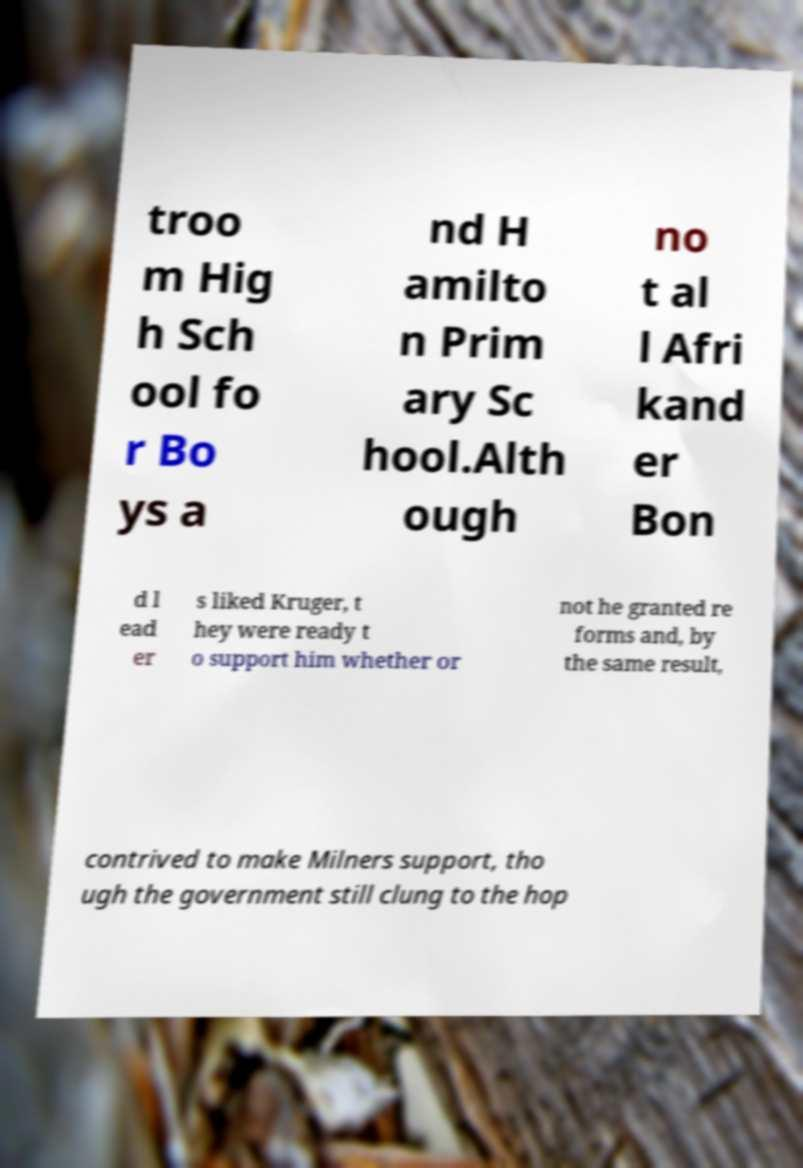Please read and relay the text visible in this image. What does it say? troo m Hig h Sch ool fo r Bo ys a nd H amilto n Prim ary Sc hool.Alth ough no t al l Afri kand er Bon d l ead er s liked Kruger, t hey were ready t o support him whether or not he granted re forms and, by the same result, contrived to make Milners support, tho ugh the government still clung to the hop 